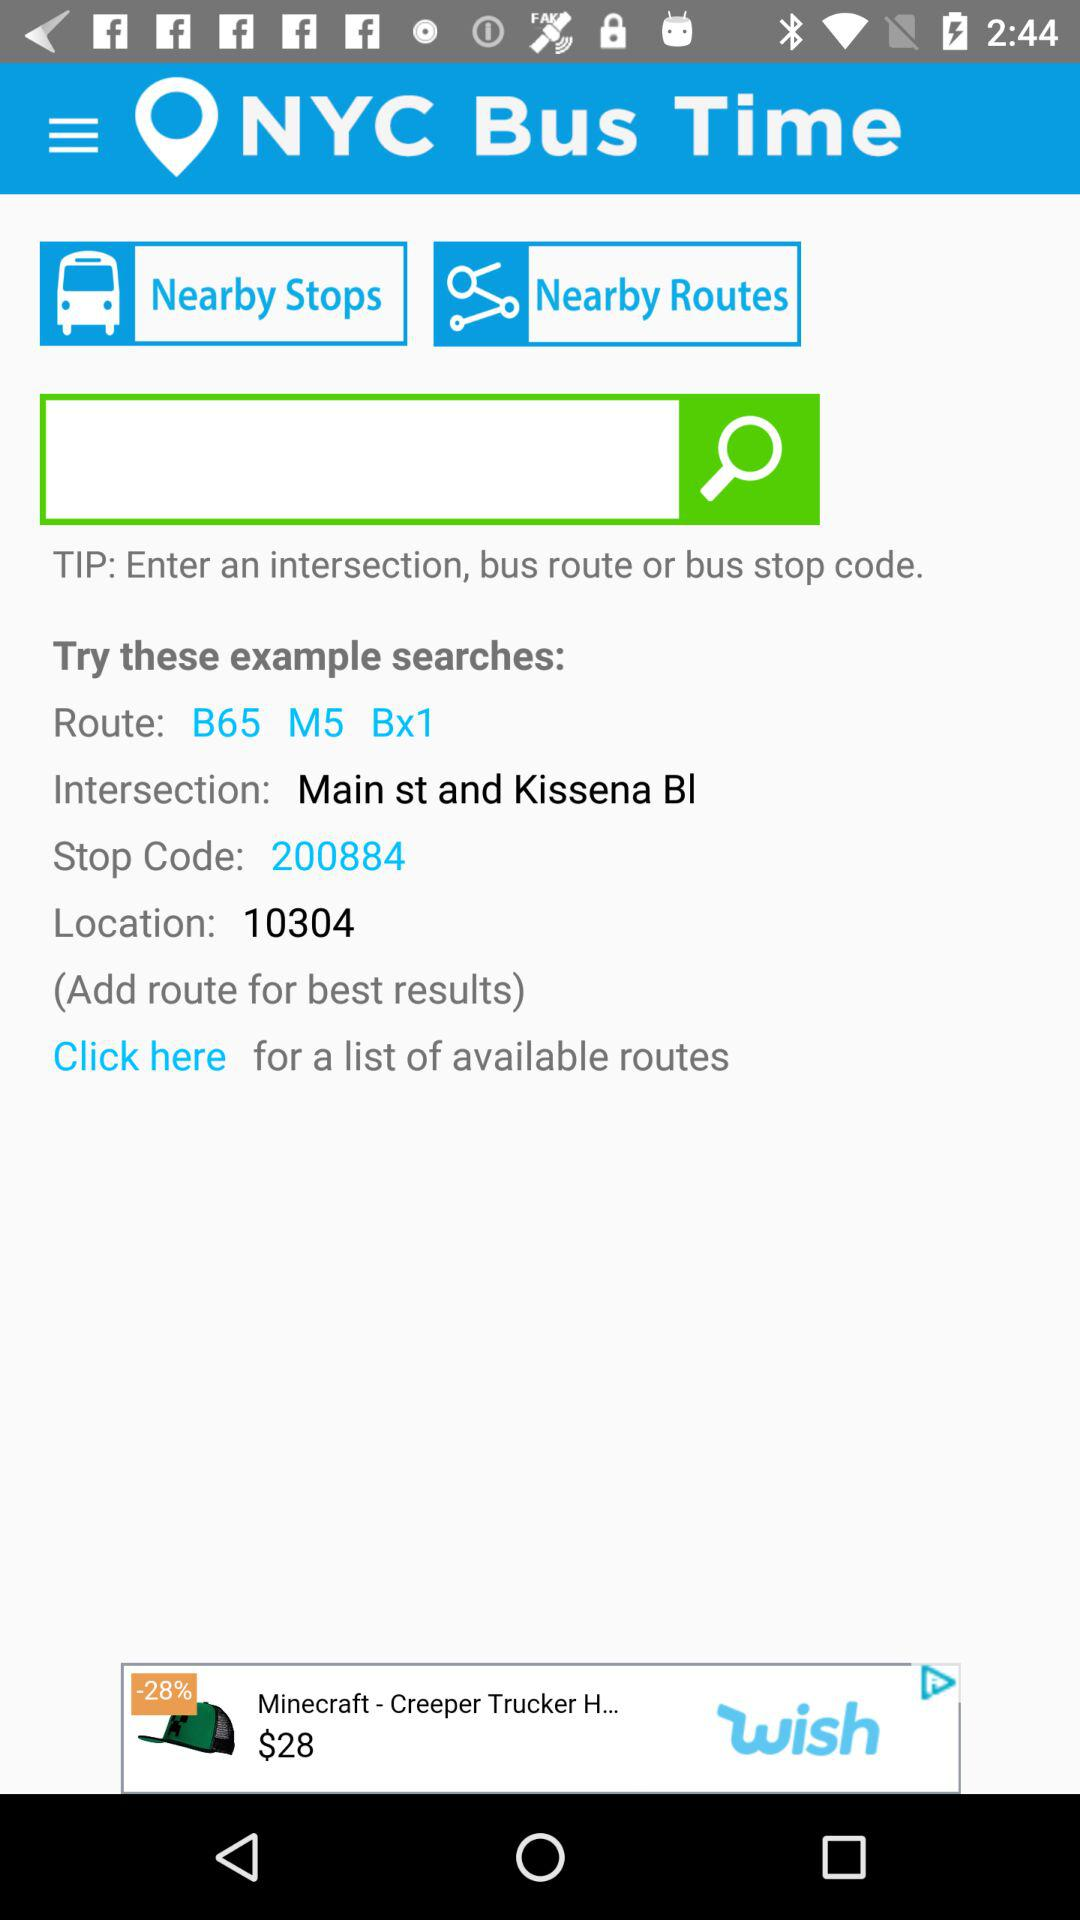What is the stop code? The stop code is 200884. 